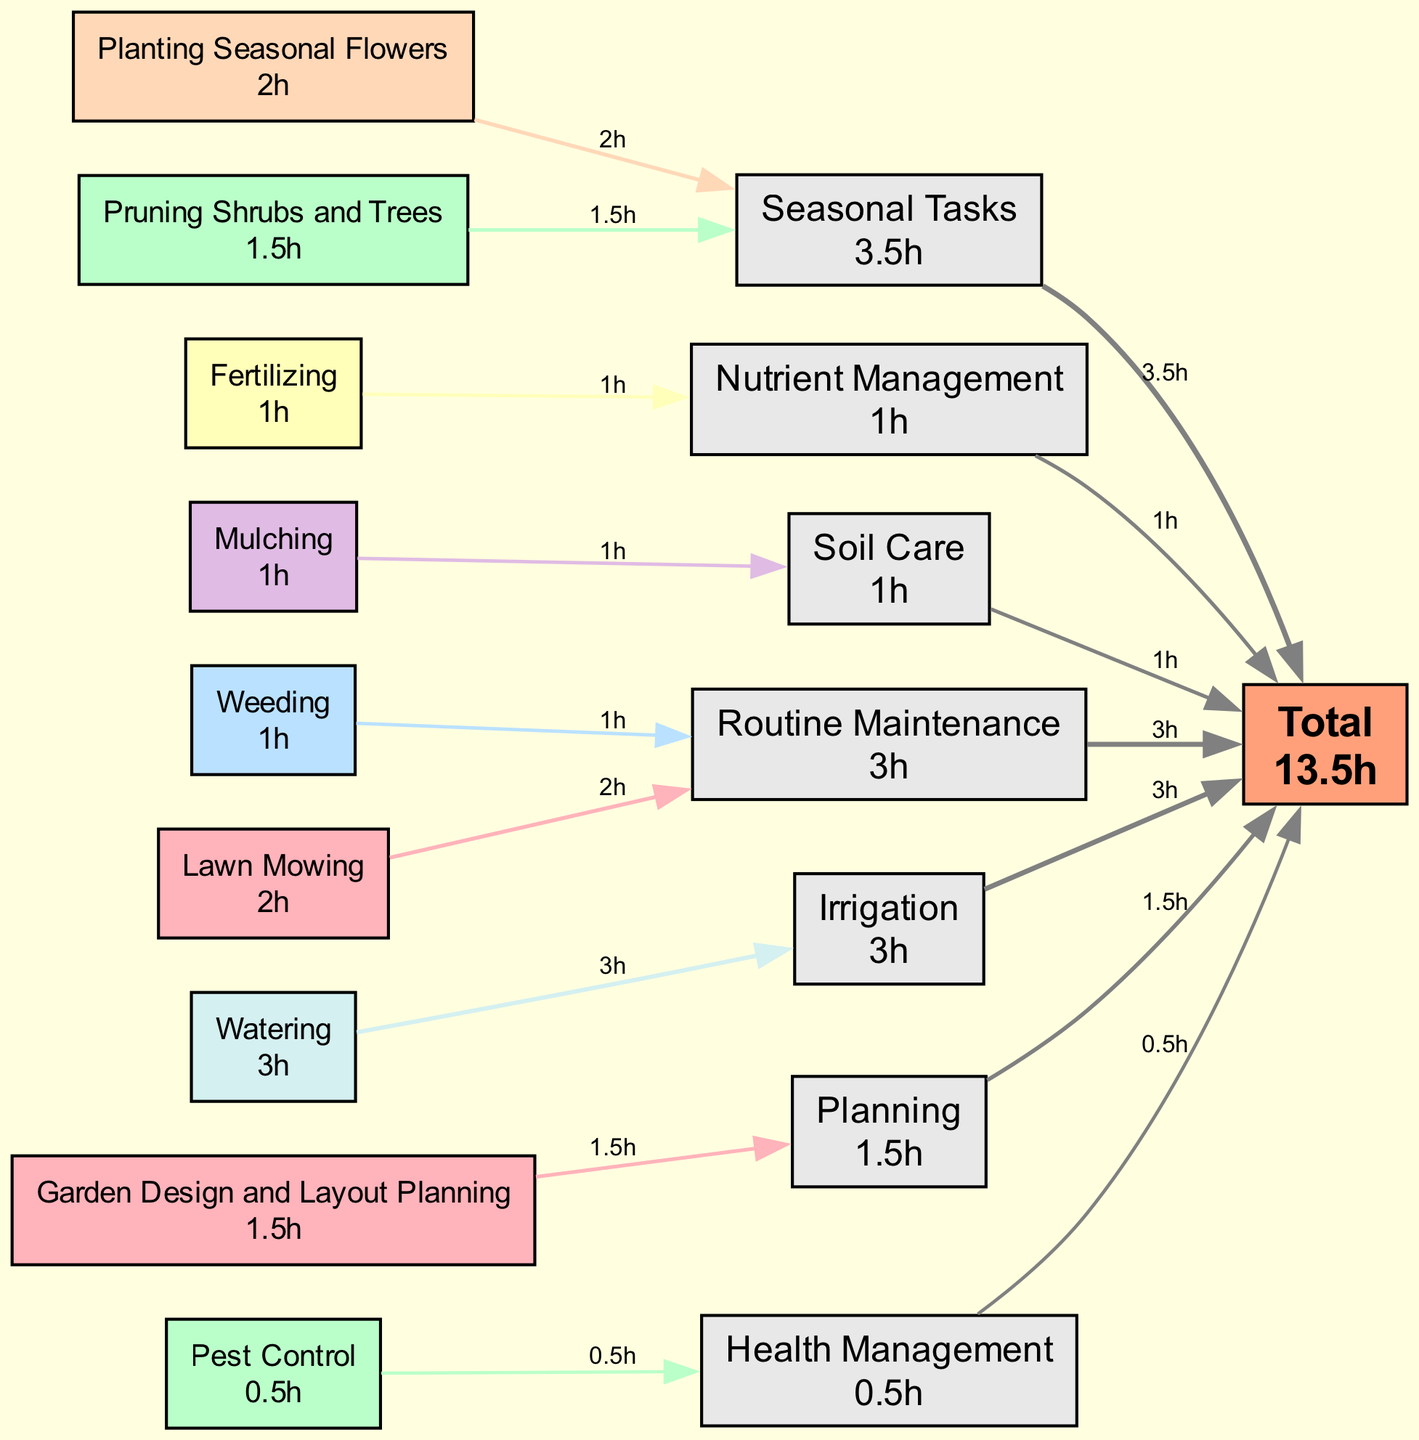What is the total number of hours dedicated to garden maintenance? To find the total number of hours, I look at the 'Total' node, which displays the cumulative hours from all tasks. This value is calculated as the sum of hours from all individual tasks listed in the diagram.
Answer: 12h Which task requires the most hours? I need to compare the hours allocated to each task by viewing the labels on each task node. The task with the highest number of hours is 'Watering' with 3 hours.
Answer: Watering How many tasks are categorized under 'Routine Maintenance'? I can count the task nodes that have 'Routine Maintenance' as their category. In this case, there are two tasks: 'Lawn Mowing' and 'Weeding'.
Answer: 2 What is the total number of seasonal tasks? By looking at the nodes defined under the 'Seasonal Tasks' category, I count 'Pruning Shrubs and Trees' and 'Planting Seasonal Flowers' as the relevant tasks. Thus, there are two seasonal tasks.
Answer: 2 What is the flow of total hours spent on 'Nutrient Management' to the total? Starting at the 'Fertilizing' task in the 'Nutrient Management' category, it shows 1 hour flows to the total. Therefore, total hours contributed from this category to the overall total is 1 hour.
Answer: 1h Which category has the least amount of hours dedicated to it? I review the 'Health Management' category, represented by 'Pest Control' with only 0.5 hours. By comparing this with other categories, I conclude that it has the least hours allocated.
Answer: Health Management Which category has the highest total hours allocated? I begin by observing the total hours for each category. 'Irrigation' with 3 hours from 'Watering' exceeds all other categories, making it the highest.
Answer: Irrigation How much time is spent on 'Soil Care'? I check the 'Soil Care' category, which is represented by the task 'Mulching'. The node indicates that 1 hour is spent under this category.
Answer: 1h 